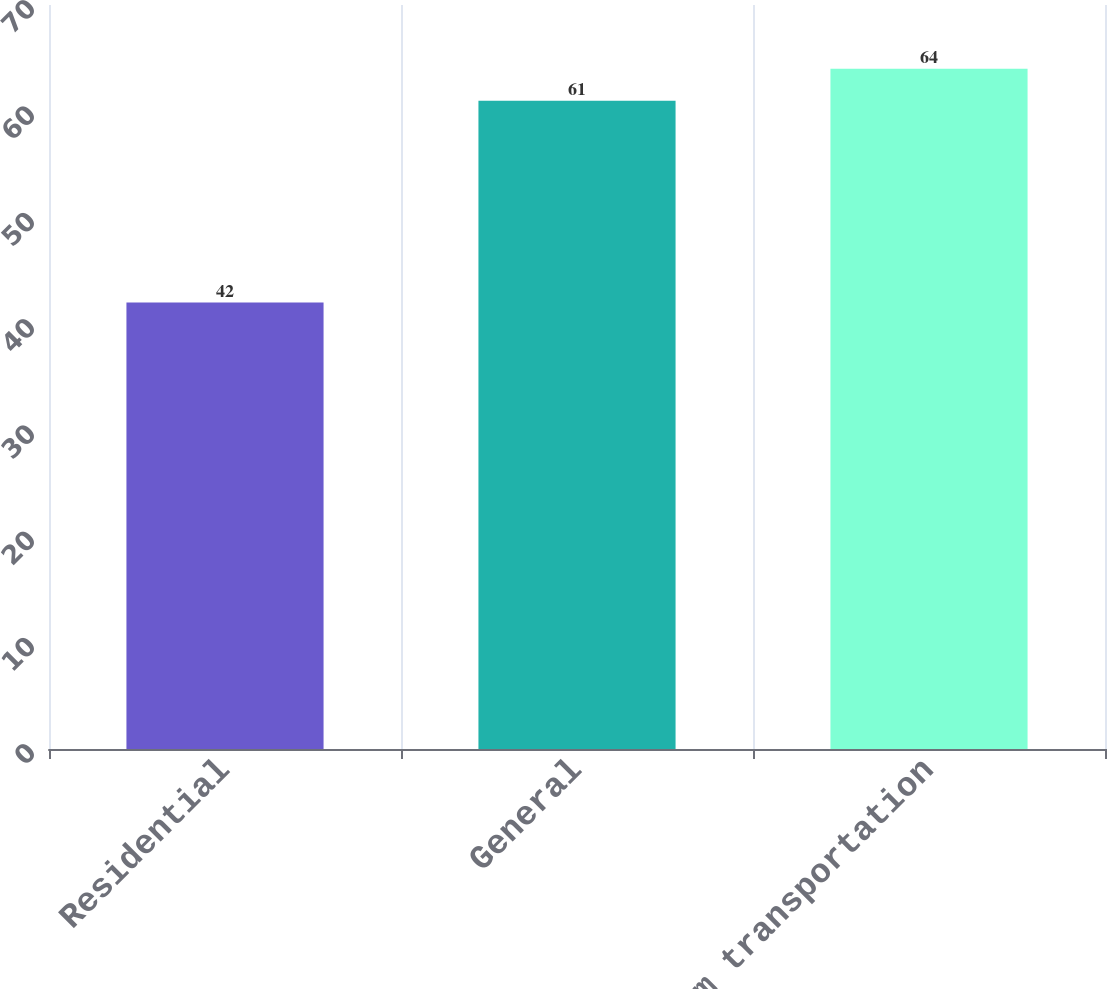<chart> <loc_0><loc_0><loc_500><loc_500><bar_chart><fcel>Residential<fcel>General<fcel>Firm transportation<nl><fcel>42<fcel>61<fcel>64<nl></chart> 